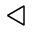Convert formula to latex. <formula><loc_0><loc_0><loc_500><loc_500>\triangleleft</formula> 